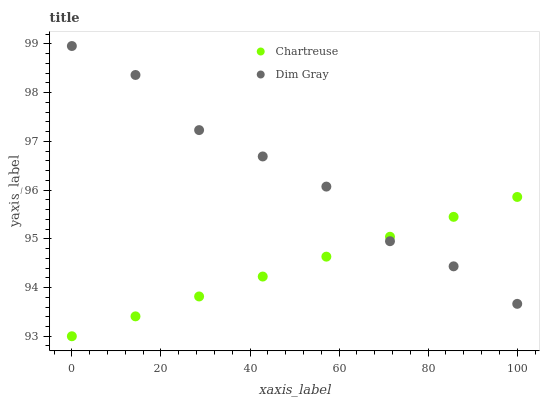Does Chartreuse have the minimum area under the curve?
Answer yes or no. Yes. Does Dim Gray have the maximum area under the curve?
Answer yes or no. Yes. Does Dim Gray have the minimum area under the curve?
Answer yes or no. No. Is Chartreuse the smoothest?
Answer yes or no. Yes. Is Dim Gray the roughest?
Answer yes or no. Yes. Is Dim Gray the smoothest?
Answer yes or no. No. Does Chartreuse have the lowest value?
Answer yes or no. Yes. Does Dim Gray have the lowest value?
Answer yes or no. No. Does Dim Gray have the highest value?
Answer yes or no. Yes. Does Dim Gray intersect Chartreuse?
Answer yes or no. Yes. Is Dim Gray less than Chartreuse?
Answer yes or no. No. Is Dim Gray greater than Chartreuse?
Answer yes or no. No. 